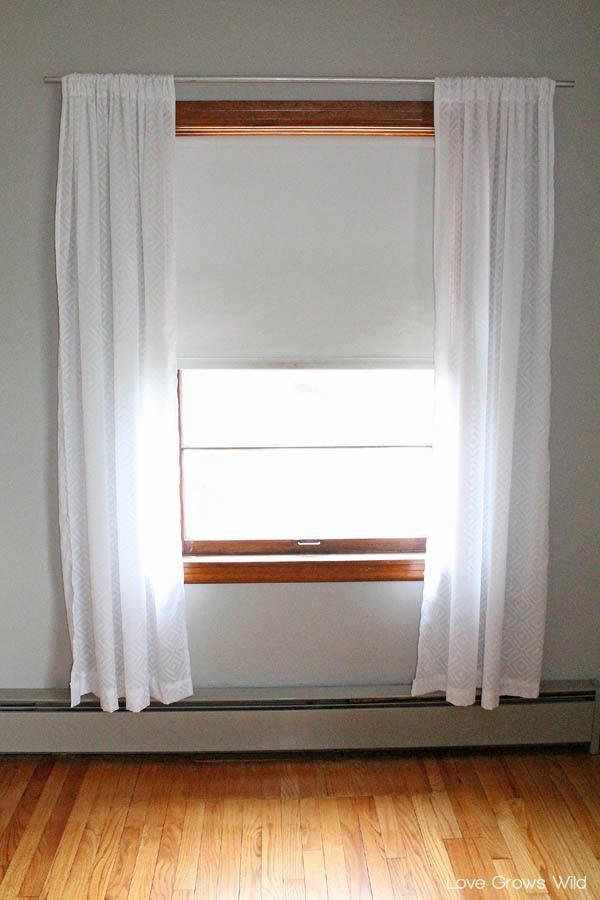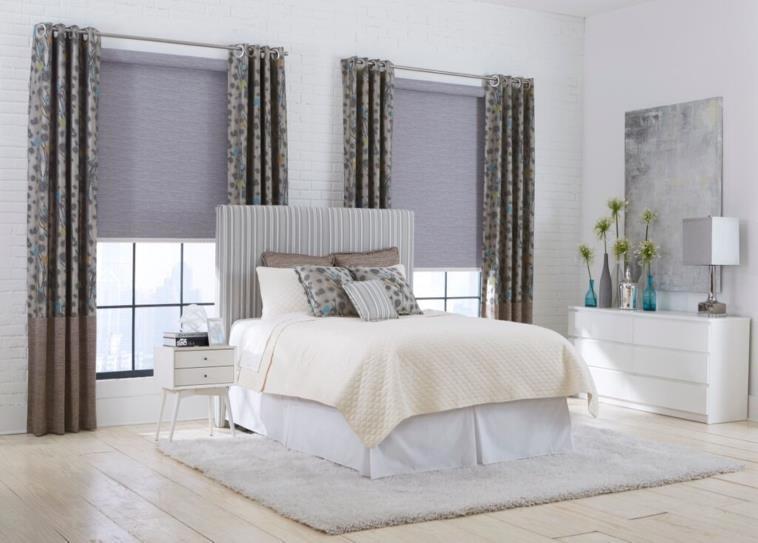The first image is the image on the left, the second image is the image on the right. Evaluate the accuracy of this statement regarding the images: "There are three partially open shades in the right image.". Is it true? Answer yes or no. No. The first image is the image on the left, the second image is the image on the right. Analyze the images presented: Is the assertion "An image shows a chandelier over a table and chairs in front of a corner with a total of three tall windows hung with solid-colored drapes in front of shades pulled half-way down." valid? Answer yes or no. No. 